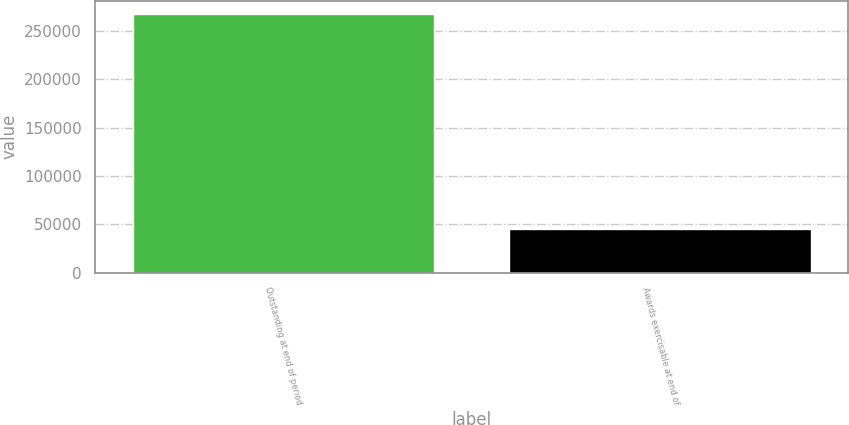<chart> <loc_0><loc_0><loc_500><loc_500><bar_chart><fcel>Outstanding at end of period<fcel>Awards exercisable at end of<nl><fcel>267981<fcel>44881<nl></chart> 